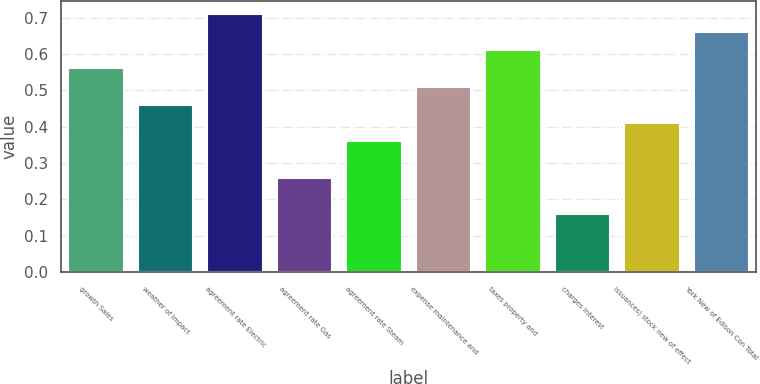Convert chart to OTSL. <chart><loc_0><loc_0><loc_500><loc_500><bar_chart><fcel>growth Sales<fcel>weather of Impact<fcel>agreement rate Electric<fcel>agreement rate Gas<fcel>agreement rate Steam<fcel>expense maintenance and<fcel>taxes property and<fcel>charges Interest<fcel>issuances) stock new of effect<fcel>York New of Edison Con Total<nl><fcel>0.56<fcel>0.46<fcel>0.71<fcel>0.26<fcel>0.36<fcel>0.51<fcel>0.61<fcel>0.16<fcel>0.41<fcel>0.66<nl></chart> 